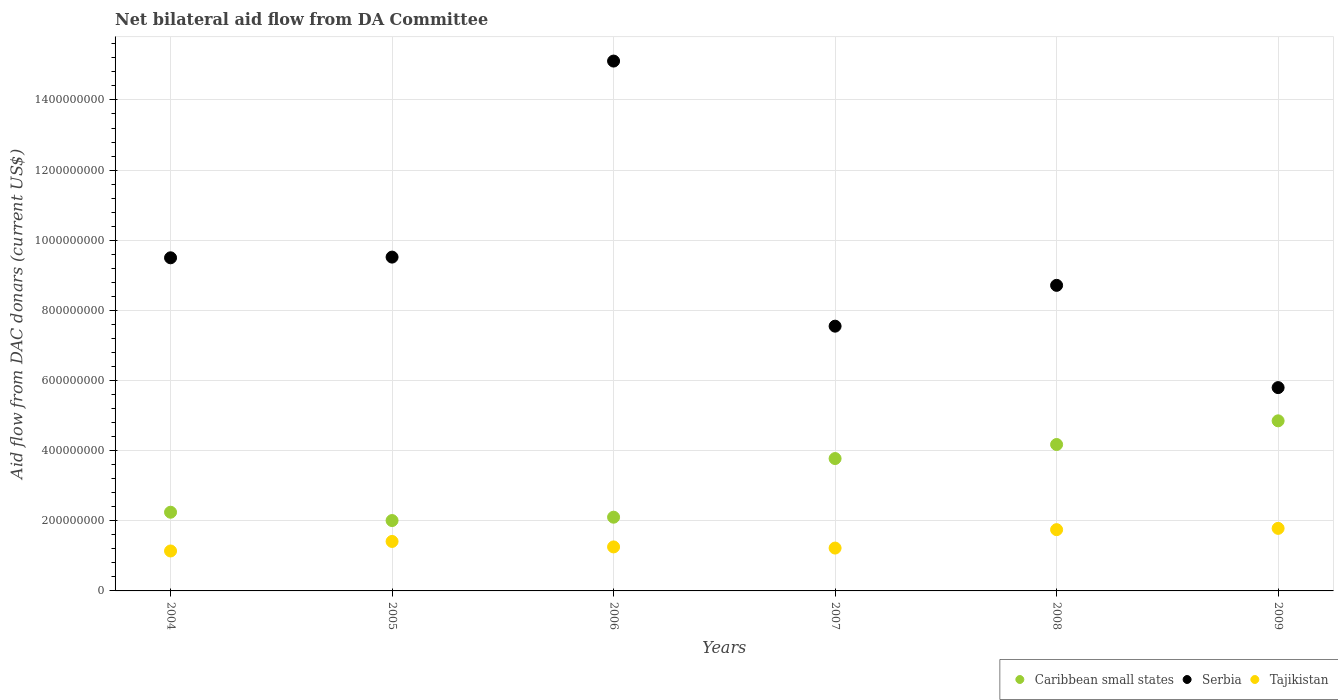Is the number of dotlines equal to the number of legend labels?
Provide a succinct answer. Yes. What is the aid flow in in Serbia in 2005?
Provide a short and direct response. 9.52e+08. Across all years, what is the maximum aid flow in in Tajikistan?
Keep it short and to the point. 1.78e+08. Across all years, what is the minimum aid flow in in Tajikistan?
Your answer should be very brief. 1.14e+08. In which year was the aid flow in in Tajikistan maximum?
Your response must be concise. 2009. In which year was the aid flow in in Serbia minimum?
Offer a very short reply. 2009. What is the total aid flow in in Caribbean small states in the graph?
Offer a very short reply. 1.92e+09. What is the difference between the aid flow in in Caribbean small states in 2005 and that in 2006?
Your answer should be very brief. -9.56e+06. What is the difference between the aid flow in in Tajikistan in 2006 and the aid flow in in Serbia in 2007?
Provide a short and direct response. -6.29e+08. What is the average aid flow in in Caribbean small states per year?
Your response must be concise. 3.19e+08. In the year 2008, what is the difference between the aid flow in in Serbia and aid flow in in Caribbean small states?
Give a very brief answer. 4.54e+08. In how many years, is the aid flow in in Serbia greater than 520000000 US$?
Your answer should be very brief. 6. What is the ratio of the aid flow in in Caribbean small states in 2005 to that in 2007?
Make the answer very short. 0.53. What is the difference between the highest and the second highest aid flow in in Serbia?
Keep it short and to the point. 5.59e+08. What is the difference between the highest and the lowest aid flow in in Caribbean small states?
Make the answer very short. 2.84e+08. In how many years, is the aid flow in in Tajikistan greater than the average aid flow in in Tajikistan taken over all years?
Your response must be concise. 2. Does the aid flow in in Serbia monotonically increase over the years?
Your answer should be compact. No. Is the aid flow in in Tajikistan strictly greater than the aid flow in in Caribbean small states over the years?
Your answer should be compact. No. Is the aid flow in in Serbia strictly less than the aid flow in in Caribbean small states over the years?
Offer a terse response. No. What is the difference between two consecutive major ticks on the Y-axis?
Give a very brief answer. 2.00e+08. Are the values on the major ticks of Y-axis written in scientific E-notation?
Your response must be concise. No. Does the graph contain grids?
Give a very brief answer. Yes. Where does the legend appear in the graph?
Your answer should be very brief. Bottom right. How are the legend labels stacked?
Provide a succinct answer. Horizontal. What is the title of the graph?
Offer a very short reply. Net bilateral aid flow from DA Committee. Does "Uganda" appear as one of the legend labels in the graph?
Keep it short and to the point. No. What is the label or title of the X-axis?
Offer a terse response. Years. What is the label or title of the Y-axis?
Ensure brevity in your answer.  Aid flow from DAC donars (current US$). What is the Aid flow from DAC donars (current US$) in Caribbean small states in 2004?
Provide a short and direct response. 2.24e+08. What is the Aid flow from DAC donars (current US$) in Serbia in 2004?
Provide a short and direct response. 9.50e+08. What is the Aid flow from DAC donars (current US$) in Tajikistan in 2004?
Offer a terse response. 1.14e+08. What is the Aid flow from DAC donars (current US$) of Caribbean small states in 2005?
Provide a short and direct response. 2.01e+08. What is the Aid flow from DAC donars (current US$) of Serbia in 2005?
Ensure brevity in your answer.  9.52e+08. What is the Aid flow from DAC donars (current US$) in Tajikistan in 2005?
Your response must be concise. 1.41e+08. What is the Aid flow from DAC donars (current US$) of Caribbean small states in 2006?
Make the answer very short. 2.10e+08. What is the Aid flow from DAC donars (current US$) of Serbia in 2006?
Give a very brief answer. 1.51e+09. What is the Aid flow from DAC donars (current US$) in Tajikistan in 2006?
Provide a succinct answer. 1.25e+08. What is the Aid flow from DAC donars (current US$) of Caribbean small states in 2007?
Provide a short and direct response. 3.77e+08. What is the Aid flow from DAC donars (current US$) in Serbia in 2007?
Offer a very short reply. 7.55e+08. What is the Aid flow from DAC donars (current US$) of Tajikistan in 2007?
Keep it short and to the point. 1.22e+08. What is the Aid flow from DAC donars (current US$) in Caribbean small states in 2008?
Offer a very short reply. 4.18e+08. What is the Aid flow from DAC donars (current US$) in Serbia in 2008?
Give a very brief answer. 8.71e+08. What is the Aid flow from DAC donars (current US$) in Tajikistan in 2008?
Give a very brief answer. 1.75e+08. What is the Aid flow from DAC donars (current US$) in Caribbean small states in 2009?
Your answer should be very brief. 4.85e+08. What is the Aid flow from DAC donars (current US$) of Serbia in 2009?
Your answer should be compact. 5.80e+08. What is the Aid flow from DAC donars (current US$) in Tajikistan in 2009?
Provide a succinct answer. 1.78e+08. Across all years, what is the maximum Aid flow from DAC donars (current US$) in Caribbean small states?
Provide a short and direct response. 4.85e+08. Across all years, what is the maximum Aid flow from DAC donars (current US$) in Serbia?
Offer a terse response. 1.51e+09. Across all years, what is the maximum Aid flow from DAC donars (current US$) in Tajikistan?
Your response must be concise. 1.78e+08. Across all years, what is the minimum Aid flow from DAC donars (current US$) in Caribbean small states?
Provide a succinct answer. 2.01e+08. Across all years, what is the minimum Aid flow from DAC donars (current US$) of Serbia?
Offer a terse response. 5.80e+08. Across all years, what is the minimum Aid flow from DAC donars (current US$) in Tajikistan?
Give a very brief answer. 1.14e+08. What is the total Aid flow from DAC donars (current US$) in Caribbean small states in the graph?
Give a very brief answer. 1.92e+09. What is the total Aid flow from DAC donars (current US$) in Serbia in the graph?
Offer a terse response. 5.62e+09. What is the total Aid flow from DAC donars (current US$) of Tajikistan in the graph?
Offer a very short reply. 8.56e+08. What is the difference between the Aid flow from DAC donars (current US$) of Caribbean small states in 2004 and that in 2005?
Give a very brief answer. 2.37e+07. What is the difference between the Aid flow from DAC donars (current US$) in Serbia in 2004 and that in 2005?
Your answer should be very brief. -1.97e+06. What is the difference between the Aid flow from DAC donars (current US$) of Tajikistan in 2004 and that in 2005?
Your response must be concise. -2.72e+07. What is the difference between the Aid flow from DAC donars (current US$) in Caribbean small states in 2004 and that in 2006?
Offer a very short reply. 1.42e+07. What is the difference between the Aid flow from DAC donars (current US$) in Serbia in 2004 and that in 2006?
Your answer should be compact. -5.61e+08. What is the difference between the Aid flow from DAC donars (current US$) of Tajikistan in 2004 and that in 2006?
Ensure brevity in your answer.  -1.16e+07. What is the difference between the Aid flow from DAC donars (current US$) of Caribbean small states in 2004 and that in 2007?
Offer a terse response. -1.53e+08. What is the difference between the Aid flow from DAC donars (current US$) in Serbia in 2004 and that in 2007?
Keep it short and to the point. 1.95e+08. What is the difference between the Aid flow from DAC donars (current US$) of Tajikistan in 2004 and that in 2007?
Provide a succinct answer. -8.30e+06. What is the difference between the Aid flow from DAC donars (current US$) of Caribbean small states in 2004 and that in 2008?
Provide a short and direct response. -1.93e+08. What is the difference between the Aid flow from DAC donars (current US$) in Serbia in 2004 and that in 2008?
Keep it short and to the point. 7.86e+07. What is the difference between the Aid flow from DAC donars (current US$) of Tajikistan in 2004 and that in 2008?
Provide a succinct answer. -6.08e+07. What is the difference between the Aid flow from DAC donars (current US$) of Caribbean small states in 2004 and that in 2009?
Provide a succinct answer. -2.61e+08. What is the difference between the Aid flow from DAC donars (current US$) of Serbia in 2004 and that in 2009?
Give a very brief answer. 3.70e+08. What is the difference between the Aid flow from DAC donars (current US$) of Tajikistan in 2004 and that in 2009?
Your answer should be very brief. -6.45e+07. What is the difference between the Aid flow from DAC donars (current US$) of Caribbean small states in 2005 and that in 2006?
Your response must be concise. -9.56e+06. What is the difference between the Aid flow from DAC donars (current US$) of Serbia in 2005 and that in 2006?
Keep it short and to the point. -5.59e+08. What is the difference between the Aid flow from DAC donars (current US$) in Tajikistan in 2005 and that in 2006?
Provide a short and direct response. 1.56e+07. What is the difference between the Aid flow from DAC donars (current US$) of Caribbean small states in 2005 and that in 2007?
Ensure brevity in your answer.  -1.77e+08. What is the difference between the Aid flow from DAC donars (current US$) of Serbia in 2005 and that in 2007?
Offer a very short reply. 1.97e+08. What is the difference between the Aid flow from DAC donars (current US$) of Tajikistan in 2005 and that in 2007?
Your answer should be very brief. 1.89e+07. What is the difference between the Aid flow from DAC donars (current US$) in Caribbean small states in 2005 and that in 2008?
Ensure brevity in your answer.  -2.17e+08. What is the difference between the Aid flow from DAC donars (current US$) of Serbia in 2005 and that in 2008?
Keep it short and to the point. 8.05e+07. What is the difference between the Aid flow from DAC donars (current US$) in Tajikistan in 2005 and that in 2008?
Your answer should be very brief. -3.36e+07. What is the difference between the Aid flow from DAC donars (current US$) in Caribbean small states in 2005 and that in 2009?
Keep it short and to the point. -2.84e+08. What is the difference between the Aid flow from DAC donars (current US$) of Serbia in 2005 and that in 2009?
Provide a succinct answer. 3.72e+08. What is the difference between the Aid flow from DAC donars (current US$) in Tajikistan in 2005 and that in 2009?
Your answer should be very brief. -3.73e+07. What is the difference between the Aid flow from DAC donars (current US$) in Caribbean small states in 2006 and that in 2007?
Offer a very short reply. -1.67e+08. What is the difference between the Aid flow from DAC donars (current US$) in Serbia in 2006 and that in 2007?
Ensure brevity in your answer.  7.56e+08. What is the difference between the Aid flow from DAC donars (current US$) of Tajikistan in 2006 and that in 2007?
Make the answer very short. 3.28e+06. What is the difference between the Aid flow from DAC donars (current US$) in Caribbean small states in 2006 and that in 2008?
Provide a succinct answer. -2.07e+08. What is the difference between the Aid flow from DAC donars (current US$) in Serbia in 2006 and that in 2008?
Make the answer very short. 6.40e+08. What is the difference between the Aid flow from DAC donars (current US$) in Tajikistan in 2006 and that in 2008?
Offer a very short reply. -4.92e+07. What is the difference between the Aid flow from DAC donars (current US$) in Caribbean small states in 2006 and that in 2009?
Give a very brief answer. -2.75e+08. What is the difference between the Aid flow from DAC donars (current US$) of Serbia in 2006 and that in 2009?
Your answer should be compact. 9.31e+08. What is the difference between the Aid flow from DAC donars (current US$) in Tajikistan in 2006 and that in 2009?
Your answer should be compact. -5.29e+07. What is the difference between the Aid flow from DAC donars (current US$) of Caribbean small states in 2007 and that in 2008?
Ensure brevity in your answer.  -4.00e+07. What is the difference between the Aid flow from DAC donars (current US$) in Serbia in 2007 and that in 2008?
Ensure brevity in your answer.  -1.16e+08. What is the difference between the Aid flow from DAC donars (current US$) of Tajikistan in 2007 and that in 2008?
Ensure brevity in your answer.  -5.25e+07. What is the difference between the Aid flow from DAC donars (current US$) in Caribbean small states in 2007 and that in 2009?
Provide a short and direct response. -1.08e+08. What is the difference between the Aid flow from DAC donars (current US$) of Serbia in 2007 and that in 2009?
Offer a terse response. 1.75e+08. What is the difference between the Aid flow from DAC donars (current US$) of Tajikistan in 2007 and that in 2009?
Provide a short and direct response. -5.62e+07. What is the difference between the Aid flow from DAC donars (current US$) of Caribbean small states in 2008 and that in 2009?
Provide a succinct answer. -6.75e+07. What is the difference between the Aid flow from DAC donars (current US$) in Serbia in 2008 and that in 2009?
Ensure brevity in your answer.  2.92e+08. What is the difference between the Aid flow from DAC donars (current US$) in Tajikistan in 2008 and that in 2009?
Provide a succinct answer. -3.68e+06. What is the difference between the Aid flow from DAC donars (current US$) in Caribbean small states in 2004 and the Aid flow from DAC donars (current US$) in Serbia in 2005?
Ensure brevity in your answer.  -7.27e+08. What is the difference between the Aid flow from DAC donars (current US$) in Caribbean small states in 2004 and the Aid flow from DAC donars (current US$) in Tajikistan in 2005?
Provide a short and direct response. 8.33e+07. What is the difference between the Aid flow from DAC donars (current US$) in Serbia in 2004 and the Aid flow from DAC donars (current US$) in Tajikistan in 2005?
Provide a short and direct response. 8.09e+08. What is the difference between the Aid flow from DAC donars (current US$) in Caribbean small states in 2004 and the Aid flow from DAC donars (current US$) in Serbia in 2006?
Your answer should be compact. -1.29e+09. What is the difference between the Aid flow from DAC donars (current US$) of Caribbean small states in 2004 and the Aid flow from DAC donars (current US$) of Tajikistan in 2006?
Offer a terse response. 9.89e+07. What is the difference between the Aid flow from DAC donars (current US$) in Serbia in 2004 and the Aid flow from DAC donars (current US$) in Tajikistan in 2006?
Ensure brevity in your answer.  8.24e+08. What is the difference between the Aid flow from DAC donars (current US$) of Caribbean small states in 2004 and the Aid flow from DAC donars (current US$) of Serbia in 2007?
Provide a short and direct response. -5.31e+08. What is the difference between the Aid flow from DAC donars (current US$) in Caribbean small states in 2004 and the Aid flow from DAC donars (current US$) in Tajikistan in 2007?
Your answer should be compact. 1.02e+08. What is the difference between the Aid flow from DAC donars (current US$) of Serbia in 2004 and the Aid flow from DAC donars (current US$) of Tajikistan in 2007?
Provide a succinct answer. 8.28e+08. What is the difference between the Aid flow from DAC donars (current US$) in Caribbean small states in 2004 and the Aid flow from DAC donars (current US$) in Serbia in 2008?
Make the answer very short. -6.47e+08. What is the difference between the Aid flow from DAC donars (current US$) of Caribbean small states in 2004 and the Aid flow from DAC donars (current US$) of Tajikistan in 2008?
Your answer should be very brief. 4.97e+07. What is the difference between the Aid flow from DAC donars (current US$) in Serbia in 2004 and the Aid flow from DAC donars (current US$) in Tajikistan in 2008?
Offer a very short reply. 7.75e+08. What is the difference between the Aid flow from DAC donars (current US$) of Caribbean small states in 2004 and the Aid flow from DAC donars (current US$) of Serbia in 2009?
Ensure brevity in your answer.  -3.55e+08. What is the difference between the Aid flow from DAC donars (current US$) of Caribbean small states in 2004 and the Aid flow from DAC donars (current US$) of Tajikistan in 2009?
Provide a succinct answer. 4.60e+07. What is the difference between the Aid flow from DAC donars (current US$) in Serbia in 2004 and the Aid flow from DAC donars (current US$) in Tajikistan in 2009?
Make the answer very short. 7.72e+08. What is the difference between the Aid flow from DAC donars (current US$) of Caribbean small states in 2005 and the Aid flow from DAC donars (current US$) of Serbia in 2006?
Keep it short and to the point. -1.31e+09. What is the difference between the Aid flow from DAC donars (current US$) of Caribbean small states in 2005 and the Aid flow from DAC donars (current US$) of Tajikistan in 2006?
Make the answer very short. 7.52e+07. What is the difference between the Aid flow from DAC donars (current US$) of Serbia in 2005 and the Aid flow from DAC donars (current US$) of Tajikistan in 2006?
Your answer should be compact. 8.26e+08. What is the difference between the Aid flow from DAC donars (current US$) in Caribbean small states in 2005 and the Aid flow from DAC donars (current US$) in Serbia in 2007?
Keep it short and to the point. -5.54e+08. What is the difference between the Aid flow from DAC donars (current US$) of Caribbean small states in 2005 and the Aid flow from DAC donars (current US$) of Tajikistan in 2007?
Keep it short and to the point. 7.85e+07. What is the difference between the Aid flow from DAC donars (current US$) in Serbia in 2005 and the Aid flow from DAC donars (current US$) in Tajikistan in 2007?
Offer a terse response. 8.30e+08. What is the difference between the Aid flow from DAC donars (current US$) in Caribbean small states in 2005 and the Aid flow from DAC donars (current US$) in Serbia in 2008?
Give a very brief answer. -6.71e+08. What is the difference between the Aid flow from DAC donars (current US$) in Caribbean small states in 2005 and the Aid flow from DAC donars (current US$) in Tajikistan in 2008?
Offer a terse response. 2.60e+07. What is the difference between the Aid flow from DAC donars (current US$) of Serbia in 2005 and the Aid flow from DAC donars (current US$) of Tajikistan in 2008?
Ensure brevity in your answer.  7.77e+08. What is the difference between the Aid flow from DAC donars (current US$) in Caribbean small states in 2005 and the Aid flow from DAC donars (current US$) in Serbia in 2009?
Provide a succinct answer. -3.79e+08. What is the difference between the Aid flow from DAC donars (current US$) of Caribbean small states in 2005 and the Aid flow from DAC donars (current US$) of Tajikistan in 2009?
Your response must be concise. 2.23e+07. What is the difference between the Aid flow from DAC donars (current US$) of Serbia in 2005 and the Aid flow from DAC donars (current US$) of Tajikistan in 2009?
Your answer should be very brief. 7.73e+08. What is the difference between the Aid flow from DAC donars (current US$) in Caribbean small states in 2006 and the Aid flow from DAC donars (current US$) in Serbia in 2007?
Ensure brevity in your answer.  -5.45e+08. What is the difference between the Aid flow from DAC donars (current US$) of Caribbean small states in 2006 and the Aid flow from DAC donars (current US$) of Tajikistan in 2007?
Your answer should be compact. 8.80e+07. What is the difference between the Aid flow from DAC donars (current US$) in Serbia in 2006 and the Aid flow from DAC donars (current US$) in Tajikistan in 2007?
Your answer should be compact. 1.39e+09. What is the difference between the Aid flow from DAC donars (current US$) in Caribbean small states in 2006 and the Aid flow from DAC donars (current US$) in Serbia in 2008?
Offer a very short reply. -6.61e+08. What is the difference between the Aid flow from DAC donars (current US$) of Caribbean small states in 2006 and the Aid flow from DAC donars (current US$) of Tajikistan in 2008?
Give a very brief answer. 3.55e+07. What is the difference between the Aid flow from DAC donars (current US$) in Serbia in 2006 and the Aid flow from DAC donars (current US$) in Tajikistan in 2008?
Make the answer very short. 1.34e+09. What is the difference between the Aid flow from DAC donars (current US$) of Caribbean small states in 2006 and the Aid flow from DAC donars (current US$) of Serbia in 2009?
Your answer should be very brief. -3.70e+08. What is the difference between the Aid flow from DAC donars (current US$) of Caribbean small states in 2006 and the Aid flow from DAC donars (current US$) of Tajikistan in 2009?
Make the answer very short. 3.18e+07. What is the difference between the Aid flow from DAC donars (current US$) in Serbia in 2006 and the Aid flow from DAC donars (current US$) in Tajikistan in 2009?
Keep it short and to the point. 1.33e+09. What is the difference between the Aid flow from DAC donars (current US$) of Caribbean small states in 2007 and the Aid flow from DAC donars (current US$) of Serbia in 2008?
Offer a very short reply. -4.94e+08. What is the difference between the Aid flow from DAC donars (current US$) of Caribbean small states in 2007 and the Aid flow from DAC donars (current US$) of Tajikistan in 2008?
Your answer should be very brief. 2.03e+08. What is the difference between the Aid flow from DAC donars (current US$) of Serbia in 2007 and the Aid flow from DAC donars (current US$) of Tajikistan in 2008?
Your answer should be very brief. 5.80e+08. What is the difference between the Aid flow from DAC donars (current US$) in Caribbean small states in 2007 and the Aid flow from DAC donars (current US$) in Serbia in 2009?
Give a very brief answer. -2.02e+08. What is the difference between the Aid flow from DAC donars (current US$) in Caribbean small states in 2007 and the Aid flow from DAC donars (current US$) in Tajikistan in 2009?
Give a very brief answer. 1.99e+08. What is the difference between the Aid flow from DAC donars (current US$) of Serbia in 2007 and the Aid flow from DAC donars (current US$) of Tajikistan in 2009?
Keep it short and to the point. 5.77e+08. What is the difference between the Aid flow from DAC donars (current US$) of Caribbean small states in 2008 and the Aid flow from DAC donars (current US$) of Serbia in 2009?
Your answer should be very brief. -1.62e+08. What is the difference between the Aid flow from DAC donars (current US$) in Caribbean small states in 2008 and the Aid flow from DAC donars (current US$) in Tajikistan in 2009?
Make the answer very short. 2.39e+08. What is the difference between the Aid flow from DAC donars (current US$) of Serbia in 2008 and the Aid flow from DAC donars (current US$) of Tajikistan in 2009?
Give a very brief answer. 6.93e+08. What is the average Aid flow from DAC donars (current US$) in Caribbean small states per year?
Provide a short and direct response. 3.19e+08. What is the average Aid flow from DAC donars (current US$) in Serbia per year?
Offer a terse response. 9.36e+08. What is the average Aid flow from DAC donars (current US$) of Tajikistan per year?
Provide a succinct answer. 1.43e+08. In the year 2004, what is the difference between the Aid flow from DAC donars (current US$) in Caribbean small states and Aid flow from DAC donars (current US$) in Serbia?
Offer a terse response. -7.25e+08. In the year 2004, what is the difference between the Aid flow from DAC donars (current US$) of Caribbean small states and Aid flow from DAC donars (current US$) of Tajikistan?
Offer a very short reply. 1.11e+08. In the year 2004, what is the difference between the Aid flow from DAC donars (current US$) in Serbia and Aid flow from DAC donars (current US$) in Tajikistan?
Your response must be concise. 8.36e+08. In the year 2005, what is the difference between the Aid flow from DAC donars (current US$) of Caribbean small states and Aid flow from DAC donars (current US$) of Serbia?
Your response must be concise. -7.51e+08. In the year 2005, what is the difference between the Aid flow from DAC donars (current US$) in Caribbean small states and Aid flow from DAC donars (current US$) in Tajikistan?
Your answer should be compact. 5.96e+07. In the year 2005, what is the difference between the Aid flow from DAC donars (current US$) in Serbia and Aid flow from DAC donars (current US$) in Tajikistan?
Your response must be concise. 8.11e+08. In the year 2006, what is the difference between the Aid flow from DAC donars (current US$) in Caribbean small states and Aid flow from DAC donars (current US$) in Serbia?
Ensure brevity in your answer.  -1.30e+09. In the year 2006, what is the difference between the Aid flow from DAC donars (current US$) of Caribbean small states and Aid flow from DAC donars (current US$) of Tajikistan?
Provide a succinct answer. 8.48e+07. In the year 2006, what is the difference between the Aid flow from DAC donars (current US$) in Serbia and Aid flow from DAC donars (current US$) in Tajikistan?
Offer a terse response. 1.39e+09. In the year 2007, what is the difference between the Aid flow from DAC donars (current US$) of Caribbean small states and Aid flow from DAC donars (current US$) of Serbia?
Ensure brevity in your answer.  -3.77e+08. In the year 2007, what is the difference between the Aid flow from DAC donars (current US$) in Caribbean small states and Aid flow from DAC donars (current US$) in Tajikistan?
Keep it short and to the point. 2.55e+08. In the year 2007, what is the difference between the Aid flow from DAC donars (current US$) in Serbia and Aid flow from DAC donars (current US$) in Tajikistan?
Give a very brief answer. 6.33e+08. In the year 2008, what is the difference between the Aid flow from DAC donars (current US$) in Caribbean small states and Aid flow from DAC donars (current US$) in Serbia?
Your answer should be very brief. -4.54e+08. In the year 2008, what is the difference between the Aid flow from DAC donars (current US$) in Caribbean small states and Aid flow from DAC donars (current US$) in Tajikistan?
Your answer should be compact. 2.43e+08. In the year 2008, what is the difference between the Aid flow from DAC donars (current US$) of Serbia and Aid flow from DAC donars (current US$) of Tajikistan?
Ensure brevity in your answer.  6.97e+08. In the year 2009, what is the difference between the Aid flow from DAC donars (current US$) in Caribbean small states and Aid flow from DAC donars (current US$) in Serbia?
Your answer should be compact. -9.47e+07. In the year 2009, what is the difference between the Aid flow from DAC donars (current US$) in Caribbean small states and Aid flow from DAC donars (current US$) in Tajikistan?
Provide a short and direct response. 3.07e+08. In the year 2009, what is the difference between the Aid flow from DAC donars (current US$) of Serbia and Aid flow from DAC donars (current US$) of Tajikistan?
Ensure brevity in your answer.  4.01e+08. What is the ratio of the Aid flow from DAC donars (current US$) in Caribbean small states in 2004 to that in 2005?
Offer a terse response. 1.12. What is the ratio of the Aid flow from DAC donars (current US$) in Tajikistan in 2004 to that in 2005?
Offer a terse response. 0.81. What is the ratio of the Aid flow from DAC donars (current US$) of Caribbean small states in 2004 to that in 2006?
Make the answer very short. 1.07. What is the ratio of the Aid flow from DAC donars (current US$) of Serbia in 2004 to that in 2006?
Ensure brevity in your answer.  0.63. What is the ratio of the Aid flow from DAC donars (current US$) of Tajikistan in 2004 to that in 2006?
Ensure brevity in your answer.  0.91. What is the ratio of the Aid flow from DAC donars (current US$) of Caribbean small states in 2004 to that in 2007?
Your answer should be compact. 0.59. What is the ratio of the Aid flow from DAC donars (current US$) of Serbia in 2004 to that in 2007?
Your answer should be compact. 1.26. What is the ratio of the Aid flow from DAC donars (current US$) of Tajikistan in 2004 to that in 2007?
Provide a succinct answer. 0.93. What is the ratio of the Aid flow from DAC donars (current US$) of Caribbean small states in 2004 to that in 2008?
Ensure brevity in your answer.  0.54. What is the ratio of the Aid flow from DAC donars (current US$) of Serbia in 2004 to that in 2008?
Offer a terse response. 1.09. What is the ratio of the Aid flow from DAC donars (current US$) of Tajikistan in 2004 to that in 2008?
Your response must be concise. 0.65. What is the ratio of the Aid flow from DAC donars (current US$) of Caribbean small states in 2004 to that in 2009?
Your response must be concise. 0.46. What is the ratio of the Aid flow from DAC donars (current US$) in Serbia in 2004 to that in 2009?
Ensure brevity in your answer.  1.64. What is the ratio of the Aid flow from DAC donars (current US$) in Tajikistan in 2004 to that in 2009?
Your answer should be very brief. 0.64. What is the ratio of the Aid flow from DAC donars (current US$) of Caribbean small states in 2005 to that in 2006?
Ensure brevity in your answer.  0.95. What is the ratio of the Aid flow from DAC donars (current US$) of Serbia in 2005 to that in 2006?
Offer a terse response. 0.63. What is the ratio of the Aid flow from DAC donars (current US$) of Tajikistan in 2005 to that in 2006?
Offer a very short reply. 1.12. What is the ratio of the Aid flow from DAC donars (current US$) in Caribbean small states in 2005 to that in 2007?
Give a very brief answer. 0.53. What is the ratio of the Aid flow from DAC donars (current US$) of Serbia in 2005 to that in 2007?
Offer a terse response. 1.26. What is the ratio of the Aid flow from DAC donars (current US$) in Tajikistan in 2005 to that in 2007?
Provide a short and direct response. 1.15. What is the ratio of the Aid flow from DAC donars (current US$) in Caribbean small states in 2005 to that in 2008?
Your answer should be very brief. 0.48. What is the ratio of the Aid flow from DAC donars (current US$) in Serbia in 2005 to that in 2008?
Make the answer very short. 1.09. What is the ratio of the Aid flow from DAC donars (current US$) in Tajikistan in 2005 to that in 2008?
Your answer should be compact. 0.81. What is the ratio of the Aid flow from DAC donars (current US$) in Caribbean small states in 2005 to that in 2009?
Provide a short and direct response. 0.41. What is the ratio of the Aid flow from DAC donars (current US$) in Serbia in 2005 to that in 2009?
Provide a short and direct response. 1.64. What is the ratio of the Aid flow from DAC donars (current US$) in Tajikistan in 2005 to that in 2009?
Ensure brevity in your answer.  0.79. What is the ratio of the Aid flow from DAC donars (current US$) of Caribbean small states in 2006 to that in 2007?
Offer a very short reply. 0.56. What is the ratio of the Aid flow from DAC donars (current US$) in Serbia in 2006 to that in 2007?
Provide a short and direct response. 2. What is the ratio of the Aid flow from DAC donars (current US$) in Tajikistan in 2006 to that in 2007?
Provide a succinct answer. 1.03. What is the ratio of the Aid flow from DAC donars (current US$) in Caribbean small states in 2006 to that in 2008?
Your answer should be very brief. 0.5. What is the ratio of the Aid flow from DAC donars (current US$) in Serbia in 2006 to that in 2008?
Your response must be concise. 1.73. What is the ratio of the Aid flow from DAC donars (current US$) in Tajikistan in 2006 to that in 2008?
Offer a terse response. 0.72. What is the ratio of the Aid flow from DAC donars (current US$) of Caribbean small states in 2006 to that in 2009?
Offer a very short reply. 0.43. What is the ratio of the Aid flow from DAC donars (current US$) of Serbia in 2006 to that in 2009?
Your answer should be compact. 2.61. What is the ratio of the Aid flow from DAC donars (current US$) in Tajikistan in 2006 to that in 2009?
Provide a succinct answer. 0.7. What is the ratio of the Aid flow from DAC donars (current US$) in Caribbean small states in 2007 to that in 2008?
Offer a terse response. 0.9. What is the ratio of the Aid flow from DAC donars (current US$) in Serbia in 2007 to that in 2008?
Give a very brief answer. 0.87. What is the ratio of the Aid flow from DAC donars (current US$) in Tajikistan in 2007 to that in 2008?
Provide a short and direct response. 0.7. What is the ratio of the Aid flow from DAC donars (current US$) in Caribbean small states in 2007 to that in 2009?
Your answer should be very brief. 0.78. What is the ratio of the Aid flow from DAC donars (current US$) of Serbia in 2007 to that in 2009?
Make the answer very short. 1.3. What is the ratio of the Aid flow from DAC donars (current US$) of Tajikistan in 2007 to that in 2009?
Your answer should be very brief. 0.69. What is the ratio of the Aid flow from DAC donars (current US$) of Caribbean small states in 2008 to that in 2009?
Provide a short and direct response. 0.86. What is the ratio of the Aid flow from DAC donars (current US$) in Serbia in 2008 to that in 2009?
Offer a very short reply. 1.5. What is the ratio of the Aid flow from DAC donars (current US$) in Tajikistan in 2008 to that in 2009?
Ensure brevity in your answer.  0.98. What is the difference between the highest and the second highest Aid flow from DAC donars (current US$) of Caribbean small states?
Your response must be concise. 6.75e+07. What is the difference between the highest and the second highest Aid flow from DAC donars (current US$) of Serbia?
Keep it short and to the point. 5.59e+08. What is the difference between the highest and the second highest Aid flow from DAC donars (current US$) of Tajikistan?
Offer a terse response. 3.68e+06. What is the difference between the highest and the lowest Aid flow from DAC donars (current US$) of Caribbean small states?
Provide a succinct answer. 2.84e+08. What is the difference between the highest and the lowest Aid flow from DAC donars (current US$) in Serbia?
Give a very brief answer. 9.31e+08. What is the difference between the highest and the lowest Aid flow from DAC donars (current US$) in Tajikistan?
Ensure brevity in your answer.  6.45e+07. 